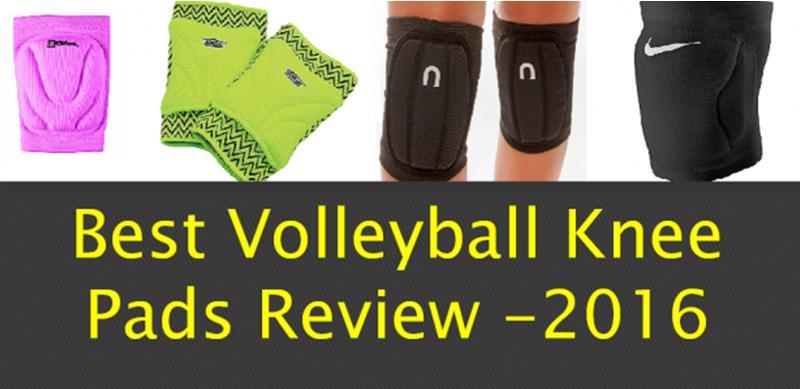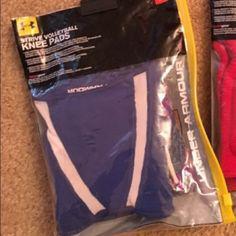The first image is the image on the left, the second image is the image on the right. Assess this claim about the two images: "An image shows legs only wearing non-bulky knee wraps, and shows three color options.". Correct or not? Answer yes or no. No. The first image is the image on the left, the second image is the image on the right. Assess this claim about the two images: "One of the images appears to contain at least three female knees.". Correct or not? Answer yes or no. No. 